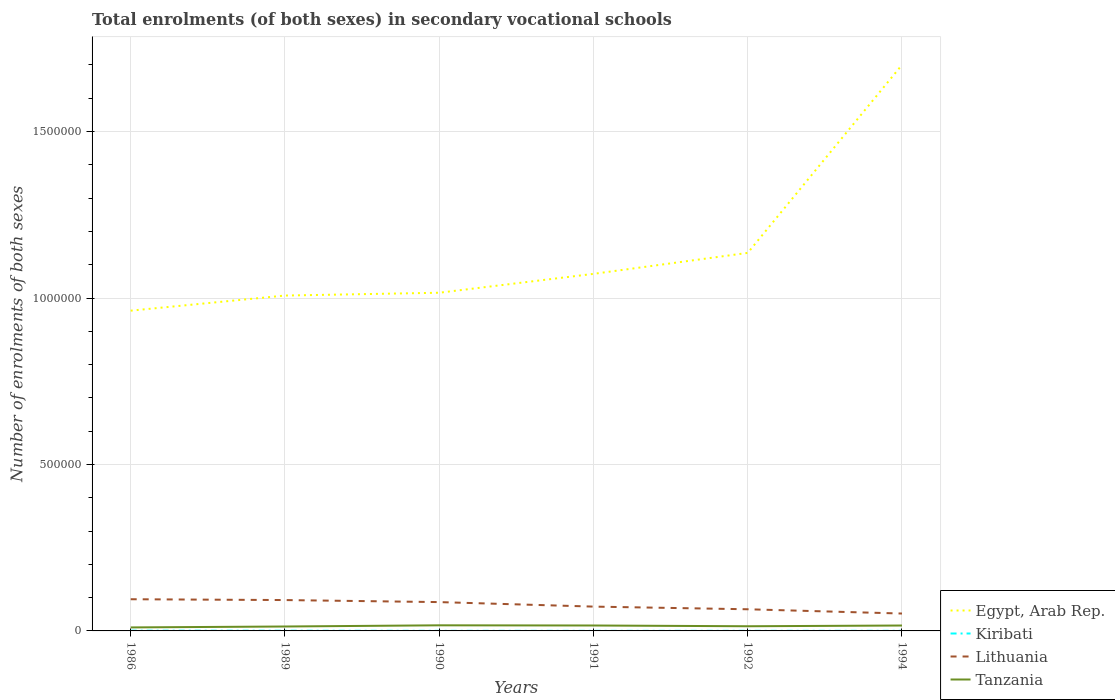How many different coloured lines are there?
Ensure brevity in your answer.  4. Across all years, what is the maximum number of enrolments in secondary schools in Kiribati?
Your answer should be very brief. 221. In which year was the number of enrolments in secondary schools in Tanzania maximum?
Your response must be concise. 1986. What is the total number of enrolments in secondary schools in Lithuania in the graph?
Keep it short and to the point. 2.21e+04. What is the difference between the highest and the second highest number of enrolments in secondary schools in Kiribati?
Keep it short and to the point. 518. What is the difference between the highest and the lowest number of enrolments in secondary schools in Egypt, Arab Rep.?
Provide a short and direct response. 1. Is the number of enrolments in secondary schools in Tanzania strictly greater than the number of enrolments in secondary schools in Kiribati over the years?
Give a very brief answer. No. How many years are there in the graph?
Offer a very short reply. 6. Does the graph contain grids?
Your answer should be compact. Yes. What is the title of the graph?
Your response must be concise. Total enrolments (of both sexes) in secondary vocational schools. Does "Hong Kong" appear as one of the legend labels in the graph?
Provide a short and direct response. No. What is the label or title of the X-axis?
Provide a short and direct response. Years. What is the label or title of the Y-axis?
Your answer should be compact. Number of enrolments of both sexes. What is the Number of enrolments of both sexes in Egypt, Arab Rep. in 1986?
Offer a terse response. 9.62e+05. What is the Number of enrolments of both sexes of Kiribati in 1986?
Keep it short and to the point. 739. What is the Number of enrolments of both sexes of Lithuania in 1986?
Provide a succinct answer. 9.52e+04. What is the Number of enrolments of both sexes of Tanzania in 1986?
Keep it short and to the point. 1.05e+04. What is the Number of enrolments of both sexes in Egypt, Arab Rep. in 1989?
Offer a very short reply. 1.01e+06. What is the Number of enrolments of both sexes in Kiribati in 1989?
Keep it short and to the point. 610. What is the Number of enrolments of both sexes in Lithuania in 1989?
Your answer should be compact. 9.27e+04. What is the Number of enrolments of both sexes of Tanzania in 1989?
Your response must be concise. 1.33e+04. What is the Number of enrolments of both sexes in Egypt, Arab Rep. in 1990?
Give a very brief answer. 1.02e+06. What is the Number of enrolments of both sexes of Kiribati in 1990?
Offer a very short reply. 290. What is the Number of enrolments of both sexes of Lithuania in 1990?
Make the answer very short. 8.66e+04. What is the Number of enrolments of both sexes of Tanzania in 1990?
Give a very brief answer. 1.68e+04. What is the Number of enrolments of both sexes in Egypt, Arab Rep. in 1991?
Your answer should be very brief. 1.07e+06. What is the Number of enrolments of both sexes of Kiribati in 1991?
Provide a succinct answer. 221. What is the Number of enrolments of both sexes of Lithuania in 1991?
Offer a very short reply. 7.30e+04. What is the Number of enrolments of both sexes in Tanzania in 1991?
Offer a very short reply. 1.63e+04. What is the Number of enrolments of both sexes in Egypt, Arab Rep. in 1992?
Your answer should be compact. 1.14e+06. What is the Number of enrolments of both sexes of Kiribati in 1992?
Ensure brevity in your answer.  288. What is the Number of enrolments of both sexes of Lithuania in 1992?
Your answer should be compact. 6.50e+04. What is the Number of enrolments of both sexes of Tanzania in 1992?
Your answer should be compact. 1.41e+04. What is the Number of enrolments of both sexes of Egypt, Arab Rep. in 1994?
Your response must be concise. 1.70e+06. What is the Number of enrolments of both sexes in Kiribati in 1994?
Your answer should be compact. 352. What is the Number of enrolments of both sexes in Lithuania in 1994?
Provide a short and direct response. 5.22e+04. What is the Number of enrolments of both sexes of Tanzania in 1994?
Keep it short and to the point. 1.63e+04. Across all years, what is the maximum Number of enrolments of both sexes of Egypt, Arab Rep.?
Make the answer very short. 1.70e+06. Across all years, what is the maximum Number of enrolments of both sexes of Kiribati?
Provide a short and direct response. 739. Across all years, what is the maximum Number of enrolments of both sexes in Lithuania?
Provide a succinct answer. 9.52e+04. Across all years, what is the maximum Number of enrolments of both sexes of Tanzania?
Provide a short and direct response. 1.68e+04. Across all years, what is the minimum Number of enrolments of both sexes of Egypt, Arab Rep.?
Your response must be concise. 9.62e+05. Across all years, what is the minimum Number of enrolments of both sexes in Kiribati?
Provide a short and direct response. 221. Across all years, what is the minimum Number of enrolments of both sexes of Lithuania?
Provide a short and direct response. 5.22e+04. Across all years, what is the minimum Number of enrolments of both sexes in Tanzania?
Make the answer very short. 1.05e+04. What is the total Number of enrolments of both sexes of Egypt, Arab Rep. in the graph?
Offer a terse response. 6.89e+06. What is the total Number of enrolments of both sexes in Kiribati in the graph?
Ensure brevity in your answer.  2500. What is the total Number of enrolments of both sexes in Lithuania in the graph?
Your response must be concise. 4.65e+05. What is the total Number of enrolments of both sexes in Tanzania in the graph?
Offer a very short reply. 8.72e+04. What is the difference between the Number of enrolments of both sexes of Egypt, Arab Rep. in 1986 and that in 1989?
Offer a terse response. -4.54e+04. What is the difference between the Number of enrolments of both sexes of Kiribati in 1986 and that in 1989?
Your answer should be compact. 129. What is the difference between the Number of enrolments of both sexes of Lithuania in 1986 and that in 1989?
Keep it short and to the point. 2479. What is the difference between the Number of enrolments of both sexes in Tanzania in 1986 and that in 1989?
Offer a terse response. -2736. What is the difference between the Number of enrolments of both sexes in Egypt, Arab Rep. in 1986 and that in 1990?
Offer a very short reply. -5.38e+04. What is the difference between the Number of enrolments of both sexes in Kiribati in 1986 and that in 1990?
Offer a terse response. 449. What is the difference between the Number of enrolments of both sexes in Lithuania in 1986 and that in 1990?
Your answer should be very brief. 8601. What is the difference between the Number of enrolments of both sexes in Tanzania in 1986 and that in 1990?
Your answer should be very brief. -6323. What is the difference between the Number of enrolments of both sexes in Egypt, Arab Rep. in 1986 and that in 1991?
Offer a very short reply. -1.11e+05. What is the difference between the Number of enrolments of both sexes of Kiribati in 1986 and that in 1991?
Keep it short and to the point. 518. What is the difference between the Number of enrolments of both sexes in Lithuania in 1986 and that in 1991?
Offer a very short reply. 2.21e+04. What is the difference between the Number of enrolments of both sexes of Tanzania in 1986 and that in 1991?
Your answer should be compact. -5770. What is the difference between the Number of enrolments of both sexes of Egypt, Arab Rep. in 1986 and that in 1992?
Give a very brief answer. -1.74e+05. What is the difference between the Number of enrolments of both sexes of Kiribati in 1986 and that in 1992?
Ensure brevity in your answer.  451. What is the difference between the Number of enrolments of both sexes in Lithuania in 1986 and that in 1992?
Make the answer very short. 3.01e+04. What is the difference between the Number of enrolments of both sexes of Tanzania in 1986 and that in 1992?
Offer a very short reply. -3524. What is the difference between the Number of enrolments of both sexes of Egypt, Arab Rep. in 1986 and that in 1994?
Keep it short and to the point. -7.38e+05. What is the difference between the Number of enrolments of both sexes in Kiribati in 1986 and that in 1994?
Offer a terse response. 387. What is the difference between the Number of enrolments of both sexes in Lithuania in 1986 and that in 1994?
Ensure brevity in your answer.  4.30e+04. What is the difference between the Number of enrolments of both sexes in Tanzania in 1986 and that in 1994?
Offer a very short reply. -5725. What is the difference between the Number of enrolments of both sexes in Egypt, Arab Rep. in 1989 and that in 1990?
Ensure brevity in your answer.  -8436. What is the difference between the Number of enrolments of both sexes in Kiribati in 1989 and that in 1990?
Give a very brief answer. 320. What is the difference between the Number of enrolments of both sexes in Lithuania in 1989 and that in 1990?
Your response must be concise. 6122. What is the difference between the Number of enrolments of both sexes in Tanzania in 1989 and that in 1990?
Keep it short and to the point. -3587. What is the difference between the Number of enrolments of both sexes in Egypt, Arab Rep. in 1989 and that in 1991?
Ensure brevity in your answer.  -6.51e+04. What is the difference between the Number of enrolments of both sexes of Kiribati in 1989 and that in 1991?
Your answer should be compact. 389. What is the difference between the Number of enrolments of both sexes of Lithuania in 1989 and that in 1991?
Give a very brief answer. 1.96e+04. What is the difference between the Number of enrolments of both sexes in Tanzania in 1989 and that in 1991?
Provide a short and direct response. -3034. What is the difference between the Number of enrolments of both sexes of Egypt, Arab Rep. in 1989 and that in 1992?
Your answer should be very brief. -1.28e+05. What is the difference between the Number of enrolments of both sexes of Kiribati in 1989 and that in 1992?
Your answer should be very brief. 322. What is the difference between the Number of enrolments of both sexes in Lithuania in 1989 and that in 1992?
Give a very brief answer. 2.77e+04. What is the difference between the Number of enrolments of both sexes of Tanzania in 1989 and that in 1992?
Offer a very short reply. -788. What is the difference between the Number of enrolments of both sexes of Egypt, Arab Rep. in 1989 and that in 1994?
Your answer should be very brief. -6.93e+05. What is the difference between the Number of enrolments of both sexes of Kiribati in 1989 and that in 1994?
Make the answer very short. 258. What is the difference between the Number of enrolments of both sexes in Lithuania in 1989 and that in 1994?
Offer a terse response. 4.05e+04. What is the difference between the Number of enrolments of both sexes of Tanzania in 1989 and that in 1994?
Offer a terse response. -2989. What is the difference between the Number of enrolments of both sexes in Egypt, Arab Rep. in 1990 and that in 1991?
Your answer should be compact. -5.67e+04. What is the difference between the Number of enrolments of both sexes in Lithuania in 1990 and that in 1991?
Provide a short and direct response. 1.35e+04. What is the difference between the Number of enrolments of both sexes of Tanzania in 1990 and that in 1991?
Ensure brevity in your answer.  553. What is the difference between the Number of enrolments of both sexes in Egypt, Arab Rep. in 1990 and that in 1992?
Your answer should be very brief. -1.20e+05. What is the difference between the Number of enrolments of both sexes of Kiribati in 1990 and that in 1992?
Your response must be concise. 2. What is the difference between the Number of enrolments of both sexes in Lithuania in 1990 and that in 1992?
Keep it short and to the point. 2.15e+04. What is the difference between the Number of enrolments of both sexes in Tanzania in 1990 and that in 1992?
Ensure brevity in your answer.  2799. What is the difference between the Number of enrolments of both sexes of Egypt, Arab Rep. in 1990 and that in 1994?
Your response must be concise. -6.84e+05. What is the difference between the Number of enrolments of both sexes in Kiribati in 1990 and that in 1994?
Your answer should be very brief. -62. What is the difference between the Number of enrolments of both sexes of Lithuania in 1990 and that in 1994?
Ensure brevity in your answer.  3.44e+04. What is the difference between the Number of enrolments of both sexes of Tanzania in 1990 and that in 1994?
Provide a succinct answer. 598. What is the difference between the Number of enrolments of both sexes in Egypt, Arab Rep. in 1991 and that in 1992?
Ensure brevity in your answer.  -6.30e+04. What is the difference between the Number of enrolments of both sexes of Kiribati in 1991 and that in 1992?
Provide a succinct answer. -67. What is the difference between the Number of enrolments of both sexes in Lithuania in 1991 and that in 1992?
Ensure brevity in your answer.  8016. What is the difference between the Number of enrolments of both sexes of Tanzania in 1991 and that in 1992?
Make the answer very short. 2246. What is the difference between the Number of enrolments of both sexes in Egypt, Arab Rep. in 1991 and that in 1994?
Offer a terse response. -6.28e+05. What is the difference between the Number of enrolments of both sexes in Kiribati in 1991 and that in 1994?
Provide a short and direct response. -131. What is the difference between the Number of enrolments of both sexes in Lithuania in 1991 and that in 1994?
Ensure brevity in your answer.  2.08e+04. What is the difference between the Number of enrolments of both sexes of Tanzania in 1991 and that in 1994?
Your answer should be compact. 45. What is the difference between the Number of enrolments of both sexes in Egypt, Arab Rep. in 1992 and that in 1994?
Offer a very short reply. -5.65e+05. What is the difference between the Number of enrolments of both sexes of Kiribati in 1992 and that in 1994?
Provide a succinct answer. -64. What is the difference between the Number of enrolments of both sexes of Lithuania in 1992 and that in 1994?
Make the answer very short. 1.28e+04. What is the difference between the Number of enrolments of both sexes in Tanzania in 1992 and that in 1994?
Provide a short and direct response. -2201. What is the difference between the Number of enrolments of both sexes of Egypt, Arab Rep. in 1986 and the Number of enrolments of both sexes of Kiribati in 1989?
Your answer should be compact. 9.61e+05. What is the difference between the Number of enrolments of both sexes in Egypt, Arab Rep. in 1986 and the Number of enrolments of both sexes in Lithuania in 1989?
Keep it short and to the point. 8.69e+05. What is the difference between the Number of enrolments of both sexes of Egypt, Arab Rep. in 1986 and the Number of enrolments of both sexes of Tanzania in 1989?
Ensure brevity in your answer.  9.49e+05. What is the difference between the Number of enrolments of both sexes in Kiribati in 1986 and the Number of enrolments of both sexes in Lithuania in 1989?
Offer a terse response. -9.20e+04. What is the difference between the Number of enrolments of both sexes in Kiribati in 1986 and the Number of enrolments of both sexes in Tanzania in 1989?
Give a very brief answer. -1.25e+04. What is the difference between the Number of enrolments of both sexes in Lithuania in 1986 and the Number of enrolments of both sexes in Tanzania in 1989?
Offer a terse response. 8.19e+04. What is the difference between the Number of enrolments of both sexes of Egypt, Arab Rep. in 1986 and the Number of enrolments of both sexes of Kiribati in 1990?
Your answer should be very brief. 9.62e+05. What is the difference between the Number of enrolments of both sexes in Egypt, Arab Rep. in 1986 and the Number of enrolments of both sexes in Lithuania in 1990?
Offer a very short reply. 8.75e+05. What is the difference between the Number of enrolments of both sexes of Egypt, Arab Rep. in 1986 and the Number of enrolments of both sexes of Tanzania in 1990?
Offer a terse response. 9.45e+05. What is the difference between the Number of enrolments of both sexes of Kiribati in 1986 and the Number of enrolments of both sexes of Lithuania in 1990?
Provide a short and direct response. -8.58e+04. What is the difference between the Number of enrolments of both sexes in Kiribati in 1986 and the Number of enrolments of both sexes in Tanzania in 1990?
Provide a succinct answer. -1.61e+04. What is the difference between the Number of enrolments of both sexes in Lithuania in 1986 and the Number of enrolments of both sexes in Tanzania in 1990?
Keep it short and to the point. 7.83e+04. What is the difference between the Number of enrolments of both sexes in Egypt, Arab Rep. in 1986 and the Number of enrolments of both sexes in Kiribati in 1991?
Provide a succinct answer. 9.62e+05. What is the difference between the Number of enrolments of both sexes in Egypt, Arab Rep. in 1986 and the Number of enrolments of both sexes in Lithuania in 1991?
Ensure brevity in your answer.  8.89e+05. What is the difference between the Number of enrolments of both sexes of Egypt, Arab Rep. in 1986 and the Number of enrolments of both sexes of Tanzania in 1991?
Your response must be concise. 9.46e+05. What is the difference between the Number of enrolments of both sexes of Kiribati in 1986 and the Number of enrolments of both sexes of Lithuania in 1991?
Your answer should be compact. -7.23e+04. What is the difference between the Number of enrolments of both sexes of Kiribati in 1986 and the Number of enrolments of both sexes of Tanzania in 1991?
Make the answer very short. -1.56e+04. What is the difference between the Number of enrolments of both sexes of Lithuania in 1986 and the Number of enrolments of both sexes of Tanzania in 1991?
Give a very brief answer. 7.89e+04. What is the difference between the Number of enrolments of both sexes of Egypt, Arab Rep. in 1986 and the Number of enrolments of both sexes of Kiribati in 1992?
Make the answer very short. 9.62e+05. What is the difference between the Number of enrolments of both sexes in Egypt, Arab Rep. in 1986 and the Number of enrolments of both sexes in Lithuania in 1992?
Keep it short and to the point. 8.97e+05. What is the difference between the Number of enrolments of both sexes of Egypt, Arab Rep. in 1986 and the Number of enrolments of both sexes of Tanzania in 1992?
Provide a succinct answer. 9.48e+05. What is the difference between the Number of enrolments of both sexes of Kiribati in 1986 and the Number of enrolments of both sexes of Lithuania in 1992?
Your answer should be very brief. -6.43e+04. What is the difference between the Number of enrolments of both sexes of Kiribati in 1986 and the Number of enrolments of both sexes of Tanzania in 1992?
Give a very brief answer. -1.33e+04. What is the difference between the Number of enrolments of both sexes of Lithuania in 1986 and the Number of enrolments of both sexes of Tanzania in 1992?
Your answer should be compact. 8.11e+04. What is the difference between the Number of enrolments of both sexes of Egypt, Arab Rep. in 1986 and the Number of enrolments of both sexes of Kiribati in 1994?
Your answer should be compact. 9.62e+05. What is the difference between the Number of enrolments of both sexes of Egypt, Arab Rep. in 1986 and the Number of enrolments of both sexes of Lithuania in 1994?
Keep it short and to the point. 9.10e+05. What is the difference between the Number of enrolments of both sexes in Egypt, Arab Rep. in 1986 and the Number of enrolments of both sexes in Tanzania in 1994?
Offer a terse response. 9.46e+05. What is the difference between the Number of enrolments of both sexes of Kiribati in 1986 and the Number of enrolments of both sexes of Lithuania in 1994?
Your answer should be very brief. -5.15e+04. What is the difference between the Number of enrolments of both sexes in Kiribati in 1986 and the Number of enrolments of both sexes in Tanzania in 1994?
Your response must be concise. -1.55e+04. What is the difference between the Number of enrolments of both sexes of Lithuania in 1986 and the Number of enrolments of both sexes of Tanzania in 1994?
Provide a succinct answer. 7.89e+04. What is the difference between the Number of enrolments of both sexes of Egypt, Arab Rep. in 1989 and the Number of enrolments of both sexes of Kiribati in 1990?
Your response must be concise. 1.01e+06. What is the difference between the Number of enrolments of both sexes of Egypt, Arab Rep. in 1989 and the Number of enrolments of both sexes of Lithuania in 1990?
Your answer should be very brief. 9.21e+05. What is the difference between the Number of enrolments of both sexes in Egypt, Arab Rep. in 1989 and the Number of enrolments of both sexes in Tanzania in 1990?
Offer a terse response. 9.91e+05. What is the difference between the Number of enrolments of both sexes in Kiribati in 1989 and the Number of enrolments of both sexes in Lithuania in 1990?
Provide a short and direct response. -8.60e+04. What is the difference between the Number of enrolments of both sexes in Kiribati in 1989 and the Number of enrolments of both sexes in Tanzania in 1990?
Your answer should be compact. -1.62e+04. What is the difference between the Number of enrolments of both sexes of Lithuania in 1989 and the Number of enrolments of both sexes of Tanzania in 1990?
Offer a very short reply. 7.58e+04. What is the difference between the Number of enrolments of both sexes of Egypt, Arab Rep. in 1989 and the Number of enrolments of both sexes of Kiribati in 1991?
Your answer should be very brief. 1.01e+06. What is the difference between the Number of enrolments of both sexes in Egypt, Arab Rep. in 1989 and the Number of enrolments of both sexes in Lithuania in 1991?
Provide a succinct answer. 9.34e+05. What is the difference between the Number of enrolments of both sexes in Egypt, Arab Rep. in 1989 and the Number of enrolments of both sexes in Tanzania in 1991?
Provide a succinct answer. 9.91e+05. What is the difference between the Number of enrolments of both sexes of Kiribati in 1989 and the Number of enrolments of both sexes of Lithuania in 1991?
Provide a short and direct response. -7.24e+04. What is the difference between the Number of enrolments of both sexes in Kiribati in 1989 and the Number of enrolments of both sexes in Tanzania in 1991?
Offer a very short reply. -1.57e+04. What is the difference between the Number of enrolments of both sexes of Lithuania in 1989 and the Number of enrolments of both sexes of Tanzania in 1991?
Your response must be concise. 7.64e+04. What is the difference between the Number of enrolments of both sexes in Egypt, Arab Rep. in 1989 and the Number of enrolments of both sexes in Kiribati in 1992?
Your answer should be very brief. 1.01e+06. What is the difference between the Number of enrolments of both sexes in Egypt, Arab Rep. in 1989 and the Number of enrolments of both sexes in Lithuania in 1992?
Provide a short and direct response. 9.42e+05. What is the difference between the Number of enrolments of both sexes of Egypt, Arab Rep. in 1989 and the Number of enrolments of both sexes of Tanzania in 1992?
Give a very brief answer. 9.93e+05. What is the difference between the Number of enrolments of both sexes of Kiribati in 1989 and the Number of enrolments of both sexes of Lithuania in 1992?
Offer a very short reply. -6.44e+04. What is the difference between the Number of enrolments of both sexes of Kiribati in 1989 and the Number of enrolments of both sexes of Tanzania in 1992?
Ensure brevity in your answer.  -1.34e+04. What is the difference between the Number of enrolments of both sexes of Lithuania in 1989 and the Number of enrolments of both sexes of Tanzania in 1992?
Keep it short and to the point. 7.86e+04. What is the difference between the Number of enrolments of both sexes of Egypt, Arab Rep. in 1989 and the Number of enrolments of both sexes of Kiribati in 1994?
Your response must be concise. 1.01e+06. What is the difference between the Number of enrolments of both sexes of Egypt, Arab Rep. in 1989 and the Number of enrolments of both sexes of Lithuania in 1994?
Give a very brief answer. 9.55e+05. What is the difference between the Number of enrolments of both sexes of Egypt, Arab Rep. in 1989 and the Number of enrolments of both sexes of Tanzania in 1994?
Your answer should be compact. 9.91e+05. What is the difference between the Number of enrolments of both sexes in Kiribati in 1989 and the Number of enrolments of both sexes in Lithuania in 1994?
Your response must be concise. -5.16e+04. What is the difference between the Number of enrolments of both sexes in Kiribati in 1989 and the Number of enrolments of both sexes in Tanzania in 1994?
Make the answer very short. -1.56e+04. What is the difference between the Number of enrolments of both sexes in Lithuania in 1989 and the Number of enrolments of both sexes in Tanzania in 1994?
Give a very brief answer. 7.64e+04. What is the difference between the Number of enrolments of both sexes of Egypt, Arab Rep. in 1990 and the Number of enrolments of both sexes of Kiribati in 1991?
Your response must be concise. 1.02e+06. What is the difference between the Number of enrolments of both sexes of Egypt, Arab Rep. in 1990 and the Number of enrolments of both sexes of Lithuania in 1991?
Your answer should be very brief. 9.43e+05. What is the difference between the Number of enrolments of both sexes of Egypt, Arab Rep. in 1990 and the Number of enrolments of both sexes of Tanzania in 1991?
Make the answer very short. 1.00e+06. What is the difference between the Number of enrolments of both sexes of Kiribati in 1990 and the Number of enrolments of both sexes of Lithuania in 1991?
Your response must be concise. -7.28e+04. What is the difference between the Number of enrolments of both sexes in Kiribati in 1990 and the Number of enrolments of both sexes in Tanzania in 1991?
Offer a very short reply. -1.60e+04. What is the difference between the Number of enrolments of both sexes of Lithuania in 1990 and the Number of enrolments of both sexes of Tanzania in 1991?
Your answer should be compact. 7.03e+04. What is the difference between the Number of enrolments of both sexes in Egypt, Arab Rep. in 1990 and the Number of enrolments of both sexes in Kiribati in 1992?
Provide a succinct answer. 1.02e+06. What is the difference between the Number of enrolments of both sexes of Egypt, Arab Rep. in 1990 and the Number of enrolments of both sexes of Lithuania in 1992?
Keep it short and to the point. 9.51e+05. What is the difference between the Number of enrolments of both sexes in Egypt, Arab Rep. in 1990 and the Number of enrolments of both sexes in Tanzania in 1992?
Make the answer very short. 1.00e+06. What is the difference between the Number of enrolments of both sexes of Kiribati in 1990 and the Number of enrolments of both sexes of Lithuania in 1992?
Give a very brief answer. -6.47e+04. What is the difference between the Number of enrolments of both sexes in Kiribati in 1990 and the Number of enrolments of both sexes in Tanzania in 1992?
Provide a short and direct response. -1.38e+04. What is the difference between the Number of enrolments of both sexes in Lithuania in 1990 and the Number of enrolments of both sexes in Tanzania in 1992?
Your answer should be very brief. 7.25e+04. What is the difference between the Number of enrolments of both sexes of Egypt, Arab Rep. in 1990 and the Number of enrolments of both sexes of Kiribati in 1994?
Make the answer very short. 1.02e+06. What is the difference between the Number of enrolments of both sexes of Egypt, Arab Rep. in 1990 and the Number of enrolments of both sexes of Lithuania in 1994?
Offer a very short reply. 9.64e+05. What is the difference between the Number of enrolments of both sexes of Egypt, Arab Rep. in 1990 and the Number of enrolments of both sexes of Tanzania in 1994?
Offer a very short reply. 1.00e+06. What is the difference between the Number of enrolments of both sexes in Kiribati in 1990 and the Number of enrolments of both sexes in Lithuania in 1994?
Make the answer very short. -5.19e+04. What is the difference between the Number of enrolments of both sexes in Kiribati in 1990 and the Number of enrolments of both sexes in Tanzania in 1994?
Your answer should be very brief. -1.60e+04. What is the difference between the Number of enrolments of both sexes of Lithuania in 1990 and the Number of enrolments of both sexes of Tanzania in 1994?
Your response must be concise. 7.03e+04. What is the difference between the Number of enrolments of both sexes in Egypt, Arab Rep. in 1991 and the Number of enrolments of both sexes in Kiribati in 1992?
Provide a succinct answer. 1.07e+06. What is the difference between the Number of enrolments of both sexes of Egypt, Arab Rep. in 1991 and the Number of enrolments of both sexes of Lithuania in 1992?
Your answer should be compact. 1.01e+06. What is the difference between the Number of enrolments of both sexes of Egypt, Arab Rep. in 1991 and the Number of enrolments of both sexes of Tanzania in 1992?
Your response must be concise. 1.06e+06. What is the difference between the Number of enrolments of both sexes in Kiribati in 1991 and the Number of enrolments of both sexes in Lithuania in 1992?
Your answer should be compact. -6.48e+04. What is the difference between the Number of enrolments of both sexes of Kiribati in 1991 and the Number of enrolments of both sexes of Tanzania in 1992?
Ensure brevity in your answer.  -1.38e+04. What is the difference between the Number of enrolments of both sexes of Lithuania in 1991 and the Number of enrolments of both sexes of Tanzania in 1992?
Give a very brief answer. 5.90e+04. What is the difference between the Number of enrolments of both sexes of Egypt, Arab Rep. in 1991 and the Number of enrolments of both sexes of Kiribati in 1994?
Offer a terse response. 1.07e+06. What is the difference between the Number of enrolments of both sexes in Egypt, Arab Rep. in 1991 and the Number of enrolments of both sexes in Lithuania in 1994?
Your response must be concise. 1.02e+06. What is the difference between the Number of enrolments of both sexes of Egypt, Arab Rep. in 1991 and the Number of enrolments of both sexes of Tanzania in 1994?
Provide a short and direct response. 1.06e+06. What is the difference between the Number of enrolments of both sexes in Kiribati in 1991 and the Number of enrolments of both sexes in Lithuania in 1994?
Keep it short and to the point. -5.20e+04. What is the difference between the Number of enrolments of both sexes in Kiribati in 1991 and the Number of enrolments of both sexes in Tanzania in 1994?
Your answer should be compact. -1.60e+04. What is the difference between the Number of enrolments of both sexes of Lithuania in 1991 and the Number of enrolments of both sexes of Tanzania in 1994?
Ensure brevity in your answer.  5.68e+04. What is the difference between the Number of enrolments of both sexes of Egypt, Arab Rep. in 1992 and the Number of enrolments of both sexes of Kiribati in 1994?
Your answer should be compact. 1.14e+06. What is the difference between the Number of enrolments of both sexes in Egypt, Arab Rep. in 1992 and the Number of enrolments of both sexes in Lithuania in 1994?
Give a very brief answer. 1.08e+06. What is the difference between the Number of enrolments of both sexes in Egypt, Arab Rep. in 1992 and the Number of enrolments of both sexes in Tanzania in 1994?
Your response must be concise. 1.12e+06. What is the difference between the Number of enrolments of both sexes of Kiribati in 1992 and the Number of enrolments of both sexes of Lithuania in 1994?
Ensure brevity in your answer.  -5.19e+04. What is the difference between the Number of enrolments of both sexes of Kiribati in 1992 and the Number of enrolments of both sexes of Tanzania in 1994?
Your response must be concise. -1.60e+04. What is the difference between the Number of enrolments of both sexes of Lithuania in 1992 and the Number of enrolments of both sexes of Tanzania in 1994?
Your response must be concise. 4.88e+04. What is the average Number of enrolments of both sexes in Egypt, Arab Rep. per year?
Your answer should be very brief. 1.15e+06. What is the average Number of enrolments of both sexes in Kiribati per year?
Offer a very short reply. 416.67. What is the average Number of enrolments of both sexes in Lithuania per year?
Offer a terse response. 7.75e+04. What is the average Number of enrolments of both sexes of Tanzania per year?
Your answer should be compact. 1.45e+04. In the year 1986, what is the difference between the Number of enrolments of both sexes of Egypt, Arab Rep. and Number of enrolments of both sexes of Kiribati?
Your answer should be compact. 9.61e+05. In the year 1986, what is the difference between the Number of enrolments of both sexes of Egypt, Arab Rep. and Number of enrolments of both sexes of Lithuania?
Make the answer very short. 8.67e+05. In the year 1986, what is the difference between the Number of enrolments of both sexes in Egypt, Arab Rep. and Number of enrolments of both sexes in Tanzania?
Offer a very short reply. 9.51e+05. In the year 1986, what is the difference between the Number of enrolments of both sexes in Kiribati and Number of enrolments of both sexes in Lithuania?
Offer a very short reply. -9.44e+04. In the year 1986, what is the difference between the Number of enrolments of both sexes of Kiribati and Number of enrolments of both sexes of Tanzania?
Ensure brevity in your answer.  -9788. In the year 1986, what is the difference between the Number of enrolments of both sexes of Lithuania and Number of enrolments of both sexes of Tanzania?
Your response must be concise. 8.46e+04. In the year 1989, what is the difference between the Number of enrolments of both sexes in Egypt, Arab Rep. and Number of enrolments of both sexes in Kiribati?
Make the answer very short. 1.01e+06. In the year 1989, what is the difference between the Number of enrolments of both sexes of Egypt, Arab Rep. and Number of enrolments of both sexes of Lithuania?
Keep it short and to the point. 9.15e+05. In the year 1989, what is the difference between the Number of enrolments of both sexes in Egypt, Arab Rep. and Number of enrolments of both sexes in Tanzania?
Your answer should be very brief. 9.94e+05. In the year 1989, what is the difference between the Number of enrolments of both sexes in Kiribati and Number of enrolments of both sexes in Lithuania?
Your response must be concise. -9.21e+04. In the year 1989, what is the difference between the Number of enrolments of both sexes in Kiribati and Number of enrolments of both sexes in Tanzania?
Offer a very short reply. -1.27e+04. In the year 1989, what is the difference between the Number of enrolments of both sexes of Lithuania and Number of enrolments of both sexes of Tanzania?
Keep it short and to the point. 7.94e+04. In the year 1990, what is the difference between the Number of enrolments of both sexes of Egypt, Arab Rep. and Number of enrolments of both sexes of Kiribati?
Keep it short and to the point. 1.02e+06. In the year 1990, what is the difference between the Number of enrolments of both sexes of Egypt, Arab Rep. and Number of enrolments of both sexes of Lithuania?
Your response must be concise. 9.29e+05. In the year 1990, what is the difference between the Number of enrolments of both sexes in Egypt, Arab Rep. and Number of enrolments of both sexes in Tanzania?
Make the answer very short. 9.99e+05. In the year 1990, what is the difference between the Number of enrolments of both sexes of Kiribati and Number of enrolments of both sexes of Lithuania?
Make the answer very short. -8.63e+04. In the year 1990, what is the difference between the Number of enrolments of both sexes of Kiribati and Number of enrolments of both sexes of Tanzania?
Offer a terse response. -1.66e+04. In the year 1990, what is the difference between the Number of enrolments of both sexes of Lithuania and Number of enrolments of both sexes of Tanzania?
Ensure brevity in your answer.  6.97e+04. In the year 1991, what is the difference between the Number of enrolments of both sexes in Egypt, Arab Rep. and Number of enrolments of both sexes in Kiribati?
Ensure brevity in your answer.  1.07e+06. In the year 1991, what is the difference between the Number of enrolments of both sexes of Egypt, Arab Rep. and Number of enrolments of both sexes of Lithuania?
Ensure brevity in your answer.  9.99e+05. In the year 1991, what is the difference between the Number of enrolments of both sexes in Egypt, Arab Rep. and Number of enrolments of both sexes in Tanzania?
Your answer should be compact. 1.06e+06. In the year 1991, what is the difference between the Number of enrolments of both sexes in Kiribati and Number of enrolments of both sexes in Lithuania?
Provide a succinct answer. -7.28e+04. In the year 1991, what is the difference between the Number of enrolments of both sexes of Kiribati and Number of enrolments of both sexes of Tanzania?
Offer a very short reply. -1.61e+04. In the year 1991, what is the difference between the Number of enrolments of both sexes in Lithuania and Number of enrolments of both sexes in Tanzania?
Keep it short and to the point. 5.68e+04. In the year 1992, what is the difference between the Number of enrolments of both sexes in Egypt, Arab Rep. and Number of enrolments of both sexes in Kiribati?
Ensure brevity in your answer.  1.14e+06. In the year 1992, what is the difference between the Number of enrolments of both sexes of Egypt, Arab Rep. and Number of enrolments of both sexes of Lithuania?
Your response must be concise. 1.07e+06. In the year 1992, what is the difference between the Number of enrolments of both sexes of Egypt, Arab Rep. and Number of enrolments of both sexes of Tanzania?
Offer a terse response. 1.12e+06. In the year 1992, what is the difference between the Number of enrolments of both sexes in Kiribati and Number of enrolments of both sexes in Lithuania?
Offer a very short reply. -6.47e+04. In the year 1992, what is the difference between the Number of enrolments of both sexes of Kiribati and Number of enrolments of both sexes of Tanzania?
Provide a short and direct response. -1.38e+04. In the year 1992, what is the difference between the Number of enrolments of both sexes of Lithuania and Number of enrolments of both sexes of Tanzania?
Your response must be concise. 5.10e+04. In the year 1994, what is the difference between the Number of enrolments of both sexes of Egypt, Arab Rep. and Number of enrolments of both sexes of Kiribati?
Your response must be concise. 1.70e+06. In the year 1994, what is the difference between the Number of enrolments of both sexes in Egypt, Arab Rep. and Number of enrolments of both sexes in Lithuania?
Make the answer very short. 1.65e+06. In the year 1994, what is the difference between the Number of enrolments of both sexes in Egypt, Arab Rep. and Number of enrolments of both sexes in Tanzania?
Offer a terse response. 1.68e+06. In the year 1994, what is the difference between the Number of enrolments of both sexes in Kiribati and Number of enrolments of both sexes in Lithuania?
Offer a terse response. -5.19e+04. In the year 1994, what is the difference between the Number of enrolments of both sexes of Kiribati and Number of enrolments of both sexes of Tanzania?
Offer a terse response. -1.59e+04. In the year 1994, what is the difference between the Number of enrolments of both sexes of Lithuania and Number of enrolments of both sexes of Tanzania?
Your answer should be compact. 3.60e+04. What is the ratio of the Number of enrolments of both sexes of Egypt, Arab Rep. in 1986 to that in 1989?
Offer a very short reply. 0.95. What is the ratio of the Number of enrolments of both sexes of Kiribati in 1986 to that in 1989?
Keep it short and to the point. 1.21. What is the ratio of the Number of enrolments of both sexes in Lithuania in 1986 to that in 1989?
Keep it short and to the point. 1.03. What is the ratio of the Number of enrolments of both sexes in Tanzania in 1986 to that in 1989?
Your answer should be very brief. 0.79. What is the ratio of the Number of enrolments of both sexes of Egypt, Arab Rep. in 1986 to that in 1990?
Provide a succinct answer. 0.95. What is the ratio of the Number of enrolments of both sexes of Kiribati in 1986 to that in 1990?
Your answer should be very brief. 2.55. What is the ratio of the Number of enrolments of both sexes of Lithuania in 1986 to that in 1990?
Give a very brief answer. 1.1. What is the ratio of the Number of enrolments of both sexes in Tanzania in 1986 to that in 1990?
Provide a succinct answer. 0.62. What is the ratio of the Number of enrolments of both sexes of Egypt, Arab Rep. in 1986 to that in 1991?
Your answer should be very brief. 0.9. What is the ratio of the Number of enrolments of both sexes of Kiribati in 1986 to that in 1991?
Your answer should be very brief. 3.34. What is the ratio of the Number of enrolments of both sexes in Lithuania in 1986 to that in 1991?
Provide a succinct answer. 1.3. What is the ratio of the Number of enrolments of both sexes in Tanzania in 1986 to that in 1991?
Offer a very short reply. 0.65. What is the ratio of the Number of enrolments of both sexes of Egypt, Arab Rep. in 1986 to that in 1992?
Offer a terse response. 0.85. What is the ratio of the Number of enrolments of both sexes in Kiribati in 1986 to that in 1992?
Your response must be concise. 2.57. What is the ratio of the Number of enrolments of both sexes in Lithuania in 1986 to that in 1992?
Your answer should be very brief. 1.46. What is the ratio of the Number of enrolments of both sexes of Tanzania in 1986 to that in 1992?
Provide a short and direct response. 0.75. What is the ratio of the Number of enrolments of both sexes of Egypt, Arab Rep. in 1986 to that in 1994?
Keep it short and to the point. 0.57. What is the ratio of the Number of enrolments of both sexes in Kiribati in 1986 to that in 1994?
Your answer should be very brief. 2.1. What is the ratio of the Number of enrolments of both sexes in Lithuania in 1986 to that in 1994?
Offer a terse response. 1.82. What is the ratio of the Number of enrolments of both sexes in Tanzania in 1986 to that in 1994?
Your answer should be compact. 0.65. What is the ratio of the Number of enrolments of both sexes in Kiribati in 1989 to that in 1990?
Your answer should be very brief. 2.1. What is the ratio of the Number of enrolments of both sexes of Lithuania in 1989 to that in 1990?
Your answer should be compact. 1.07. What is the ratio of the Number of enrolments of both sexes in Tanzania in 1989 to that in 1990?
Give a very brief answer. 0.79. What is the ratio of the Number of enrolments of both sexes in Egypt, Arab Rep. in 1989 to that in 1991?
Make the answer very short. 0.94. What is the ratio of the Number of enrolments of both sexes of Kiribati in 1989 to that in 1991?
Keep it short and to the point. 2.76. What is the ratio of the Number of enrolments of both sexes in Lithuania in 1989 to that in 1991?
Offer a very short reply. 1.27. What is the ratio of the Number of enrolments of both sexes in Tanzania in 1989 to that in 1991?
Provide a short and direct response. 0.81. What is the ratio of the Number of enrolments of both sexes in Egypt, Arab Rep. in 1989 to that in 1992?
Offer a terse response. 0.89. What is the ratio of the Number of enrolments of both sexes of Kiribati in 1989 to that in 1992?
Offer a very short reply. 2.12. What is the ratio of the Number of enrolments of both sexes in Lithuania in 1989 to that in 1992?
Your answer should be compact. 1.43. What is the ratio of the Number of enrolments of both sexes in Tanzania in 1989 to that in 1992?
Provide a short and direct response. 0.94. What is the ratio of the Number of enrolments of both sexes in Egypt, Arab Rep. in 1989 to that in 1994?
Your answer should be compact. 0.59. What is the ratio of the Number of enrolments of both sexes in Kiribati in 1989 to that in 1994?
Provide a short and direct response. 1.73. What is the ratio of the Number of enrolments of both sexes in Lithuania in 1989 to that in 1994?
Your answer should be compact. 1.78. What is the ratio of the Number of enrolments of both sexes in Tanzania in 1989 to that in 1994?
Provide a succinct answer. 0.82. What is the ratio of the Number of enrolments of both sexes in Egypt, Arab Rep. in 1990 to that in 1991?
Ensure brevity in your answer.  0.95. What is the ratio of the Number of enrolments of both sexes of Kiribati in 1990 to that in 1991?
Your answer should be compact. 1.31. What is the ratio of the Number of enrolments of both sexes of Lithuania in 1990 to that in 1991?
Make the answer very short. 1.19. What is the ratio of the Number of enrolments of both sexes of Tanzania in 1990 to that in 1991?
Ensure brevity in your answer.  1.03. What is the ratio of the Number of enrolments of both sexes of Egypt, Arab Rep. in 1990 to that in 1992?
Your response must be concise. 0.89. What is the ratio of the Number of enrolments of both sexes in Lithuania in 1990 to that in 1992?
Offer a terse response. 1.33. What is the ratio of the Number of enrolments of both sexes in Tanzania in 1990 to that in 1992?
Ensure brevity in your answer.  1.2. What is the ratio of the Number of enrolments of both sexes in Egypt, Arab Rep. in 1990 to that in 1994?
Keep it short and to the point. 0.6. What is the ratio of the Number of enrolments of both sexes in Kiribati in 1990 to that in 1994?
Make the answer very short. 0.82. What is the ratio of the Number of enrolments of both sexes in Lithuania in 1990 to that in 1994?
Offer a terse response. 1.66. What is the ratio of the Number of enrolments of both sexes in Tanzania in 1990 to that in 1994?
Provide a short and direct response. 1.04. What is the ratio of the Number of enrolments of both sexes in Egypt, Arab Rep. in 1991 to that in 1992?
Your answer should be compact. 0.94. What is the ratio of the Number of enrolments of both sexes in Kiribati in 1991 to that in 1992?
Offer a terse response. 0.77. What is the ratio of the Number of enrolments of both sexes in Lithuania in 1991 to that in 1992?
Keep it short and to the point. 1.12. What is the ratio of the Number of enrolments of both sexes in Tanzania in 1991 to that in 1992?
Offer a terse response. 1.16. What is the ratio of the Number of enrolments of both sexes of Egypt, Arab Rep. in 1991 to that in 1994?
Ensure brevity in your answer.  0.63. What is the ratio of the Number of enrolments of both sexes of Kiribati in 1991 to that in 1994?
Provide a short and direct response. 0.63. What is the ratio of the Number of enrolments of both sexes of Lithuania in 1991 to that in 1994?
Give a very brief answer. 1.4. What is the ratio of the Number of enrolments of both sexes in Tanzania in 1991 to that in 1994?
Your answer should be compact. 1. What is the ratio of the Number of enrolments of both sexes of Egypt, Arab Rep. in 1992 to that in 1994?
Your answer should be very brief. 0.67. What is the ratio of the Number of enrolments of both sexes in Kiribati in 1992 to that in 1994?
Offer a terse response. 0.82. What is the ratio of the Number of enrolments of both sexes of Lithuania in 1992 to that in 1994?
Offer a very short reply. 1.25. What is the ratio of the Number of enrolments of both sexes in Tanzania in 1992 to that in 1994?
Offer a terse response. 0.86. What is the difference between the highest and the second highest Number of enrolments of both sexes of Egypt, Arab Rep.?
Offer a terse response. 5.65e+05. What is the difference between the highest and the second highest Number of enrolments of both sexes of Kiribati?
Ensure brevity in your answer.  129. What is the difference between the highest and the second highest Number of enrolments of both sexes of Lithuania?
Ensure brevity in your answer.  2479. What is the difference between the highest and the second highest Number of enrolments of both sexes of Tanzania?
Keep it short and to the point. 553. What is the difference between the highest and the lowest Number of enrolments of both sexes of Egypt, Arab Rep.?
Make the answer very short. 7.38e+05. What is the difference between the highest and the lowest Number of enrolments of both sexes of Kiribati?
Your answer should be compact. 518. What is the difference between the highest and the lowest Number of enrolments of both sexes in Lithuania?
Keep it short and to the point. 4.30e+04. What is the difference between the highest and the lowest Number of enrolments of both sexes of Tanzania?
Provide a succinct answer. 6323. 